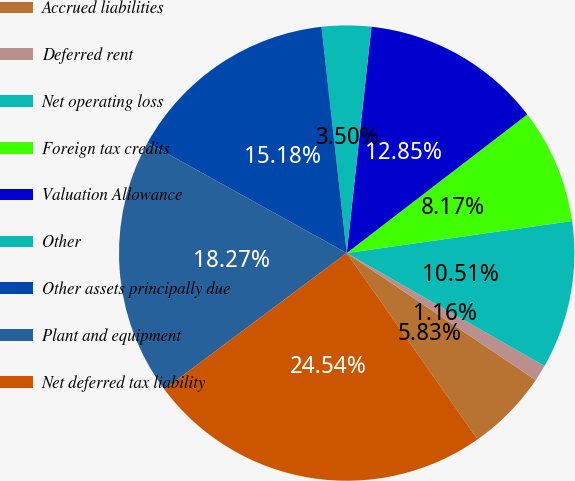<chart> <loc_0><loc_0><loc_500><loc_500><pie_chart><fcel>Accrued liabilities<fcel>Deferred rent<fcel>Net operating loss<fcel>Foreign tax credits<fcel>Valuation Allowance<fcel>Other<fcel>Other assets principally due<fcel>Plant and equipment<fcel>Net deferred tax liability<nl><fcel>5.83%<fcel>1.16%<fcel>10.51%<fcel>8.17%<fcel>12.85%<fcel>3.5%<fcel>15.18%<fcel>18.27%<fcel>24.54%<nl></chart> 